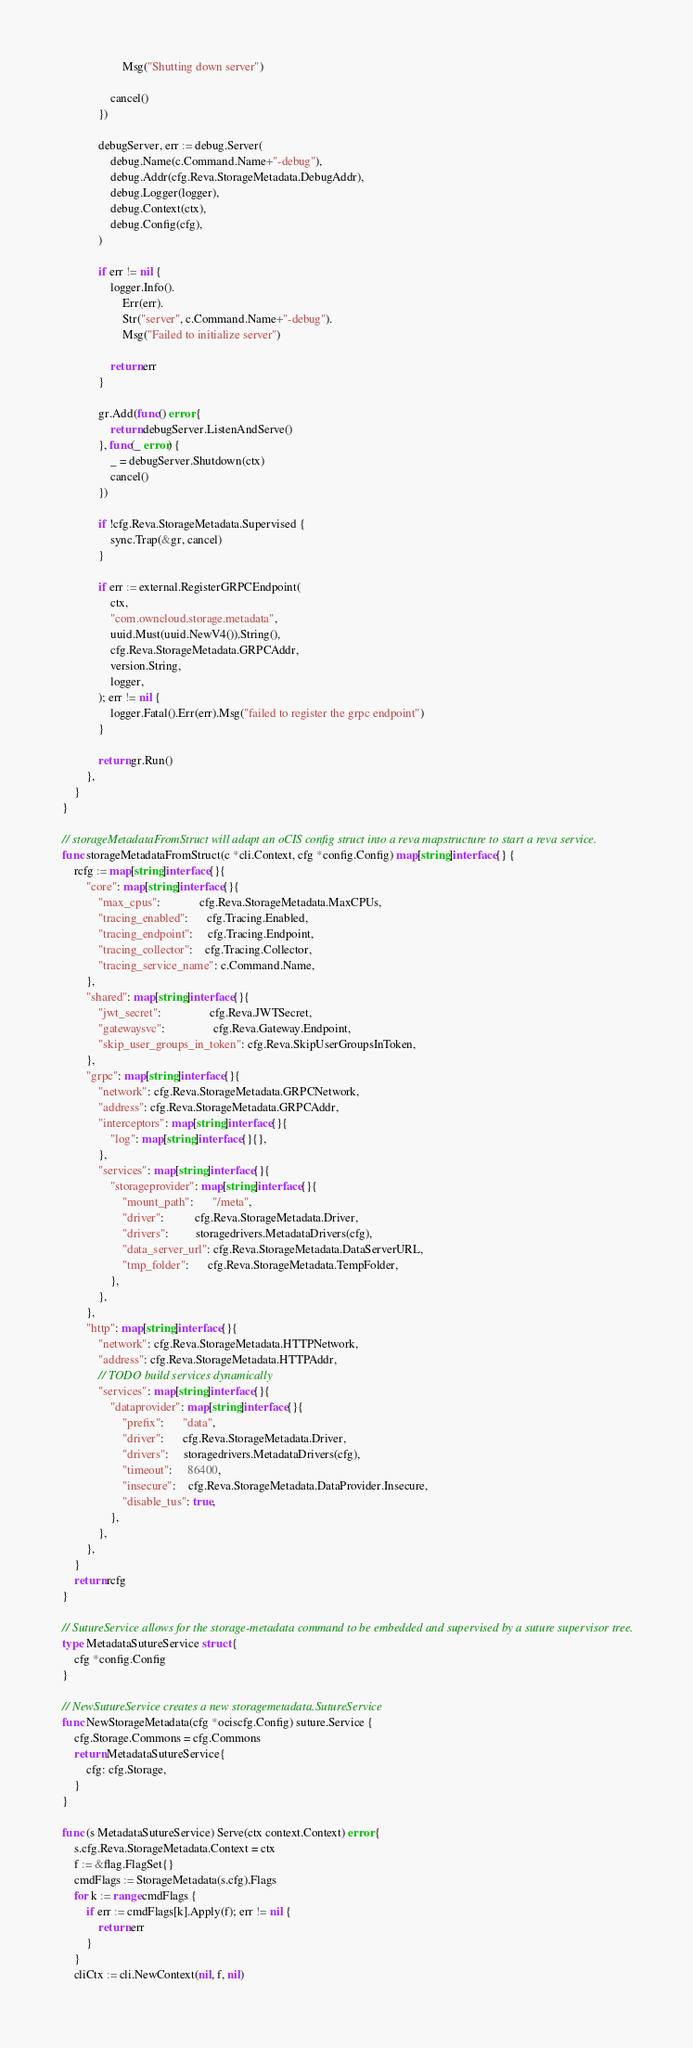<code> <loc_0><loc_0><loc_500><loc_500><_Go_>					Msg("Shutting down server")

				cancel()
			})

			debugServer, err := debug.Server(
				debug.Name(c.Command.Name+"-debug"),
				debug.Addr(cfg.Reva.StorageMetadata.DebugAddr),
				debug.Logger(logger),
				debug.Context(ctx),
				debug.Config(cfg),
			)

			if err != nil {
				logger.Info().
					Err(err).
					Str("server", c.Command.Name+"-debug").
					Msg("Failed to initialize server")

				return err
			}

			gr.Add(func() error {
				return debugServer.ListenAndServe()
			}, func(_ error) {
				_ = debugServer.Shutdown(ctx)
				cancel()
			})

			if !cfg.Reva.StorageMetadata.Supervised {
				sync.Trap(&gr, cancel)
			}

			if err := external.RegisterGRPCEndpoint(
				ctx,
				"com.owncloud.storage.metadata",
				uuid.Must(uuid.NewV4()).String(),
				cfg.Reva.StorageMetadata.GRPCAddr,
				version.String,
				logger,
			); err != nil {
				logger.Fatal().Err(err).Msg("failed to register the grpc endpoint")
			}

			return gr.Run()
		},
	}
}

// storageMetadataFromStruct will adapt an oCIS config struct into a reva mapstructure to start a reva service.
func storageMetadataFromStruct(c *cli.Context, cfg *config.Config) map[string]interface{} {
	rcfg := map[string]interface{}{
		"core": map[string]interface{}{
			"max_cpus":             cfg.Reva.StorageMetadata.MaxCPUs,
			"tracing_enabled":      cfg.Tracing.Enabled,
			"tracing_endpoint":     cfg.Tracing.Endpoint,
			"tracing_collector":    cfg.Tracing.Collector,
			"tracing_service_name": c.Command.Name,
		},
		"shared": map[string]interface{}{
			"jwt_secret":                cfg.Reva.JWTSecret,
			"gatewaysvc":                cfg.Reva.Gateway.Endpoint,
			"skip_user_groups_in_token": cfg.Reva.SkipUserGroupsInToken,
		},
		"grpc": map[string]interface{}{
			"network": cfg.Reva.StorageMetadata.GRPCNetwork,
			"address": cfg.Reva.StorageMetadata.GRPCAddr,
			"interceptors": map[string]interface{}{
				"log": map[string]interface{}{},
			},
			"services": map[string]interface{}{
				"storageprovider": map[string]interface{}{
					"mount_path":      "/meta",
					"driver":          cfg.Reva.StorageMetadata.Driver,
					"drivers":         storagedrivers.MetadataDrivers(cfg),
					"data_server_url": cfg.Reva.StorageMetadata.DataServerURL,
					"tmp_folder":      cfg.Reva.StorageMetadata.TempFolder,
				},
			},
		},
		"http": map[string]interface{}{
			"network": cfg.Reva.StorageMetadata.HTTPNetwork,
			"address": cfg.Reva.StorageMetadata.HTTPAddr,
			// TODO build services dynamically
			"services": map[string]interface{}{
				"dataprovider": map[string]interface{}{
					"prefix":      "data",
					"driver":      cfg.Reva.StorageMetadata.Driver,
					"drivers":     storagedrivers.MetadataDrivers(cfg),
					"timeout":     86400,
					"insecure":    cfg.Reva.StorageMetadata.DataProvider.Insecure,
					"disable_tus": true,
				},
			},
		},
	}
	return rcfg
}

// SutureService allows for the storage-metadata command to be embedded and supervised by a suture supervisor tree.
type MetadataSutureService struct {
	cfg *config.Config
}

// NewSutureService creates a new storagemetadata.SutureService
func NewStorageMetadata(cfg *ociscfg.Config) suture.Service {
	cfg.Storage.Commons = cfg.Commons
	return MetadataSutureService{
		cfg: cfg.Storage,
	}
}

func (s MetadataSutureService) Serve(ctx context.Context) error {
	s.cfg.Reva.StorageMetadata.Context = ctx
	f := &flag.FlagSet{}
	cmdFlags := StorageMetadata(s.cfg).Flags
	for k := range cmdFlags {
		if err := cmdFlags[k].Apply(f); err != nil {
			return err
		}
	}
	cliCtx := cli.NewContext(nil, f, nil)</code> 